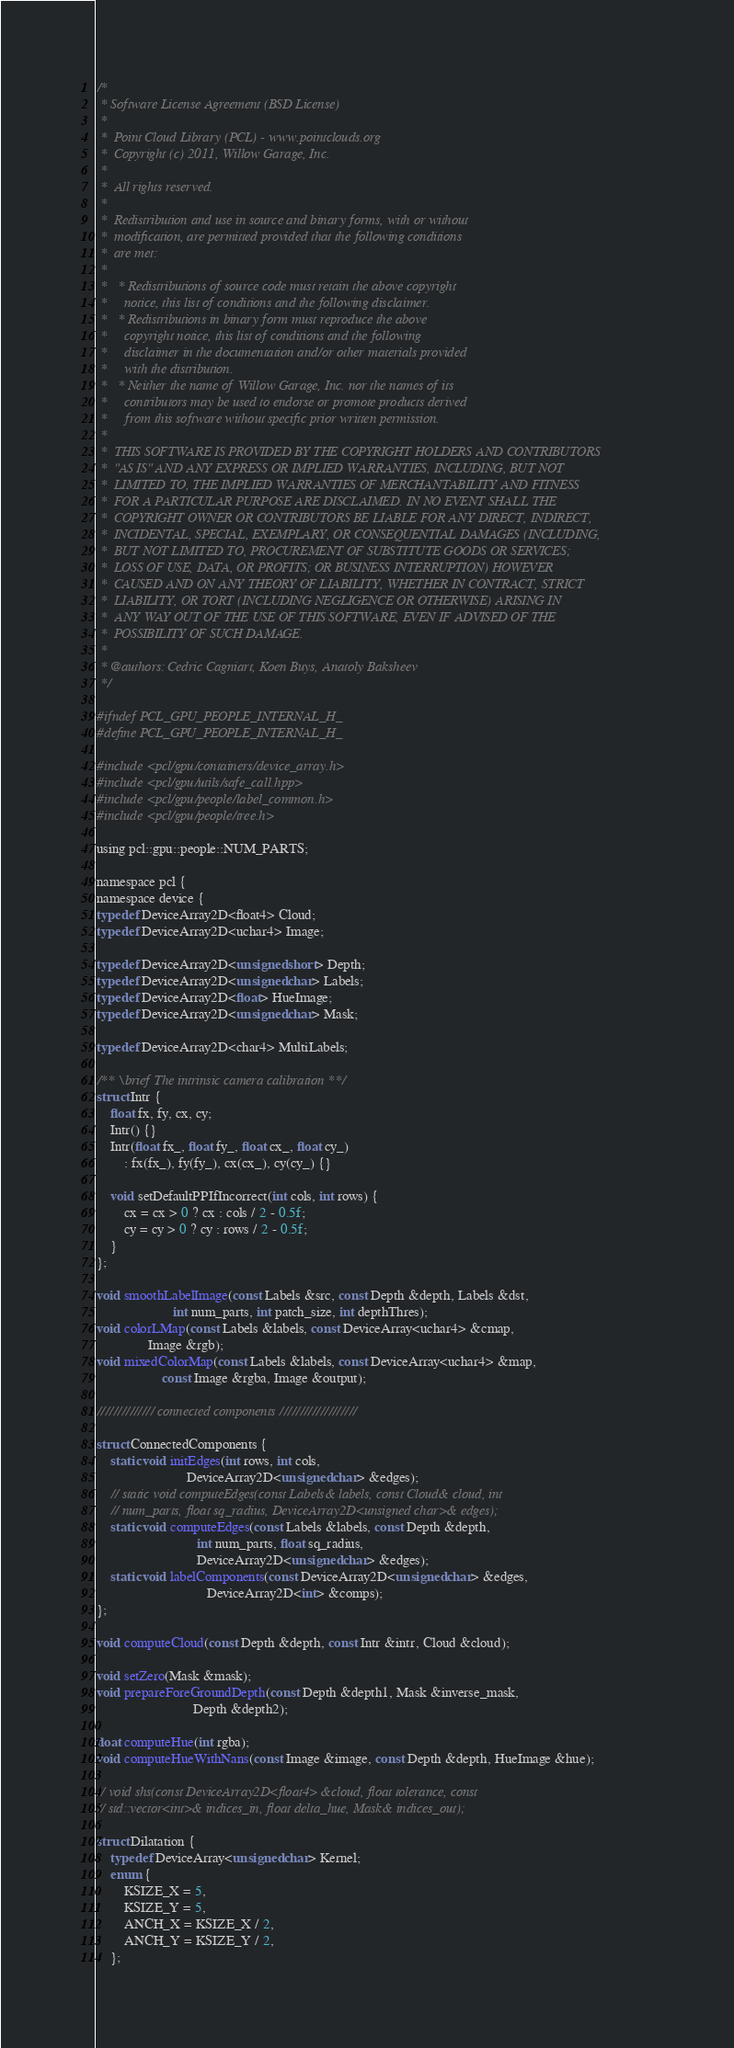Convert code to text. <code><loc_0><loc_0><loc_500><loc_500><_C_>/*
 * Software License Agreement (BSD License)
 *
 *  Point Cloud Library (PCL) - www.pointclouds.org
 *  Copyright (c) 2011, Willow Garage, Inc.
 *
 *  All rights reserved.
 *
 *  Redistribution and use in source and binary forms, with or without
 *  modification, are permitted provided that the following conditions
 *  are met:
 *
 *   * Redistributions of source code must retain the above copyright
 *     notice, this list of conditions and the following disclaimer.
 *   * Redistributions in binary form must reproduce the above
 *     copyright notice, this list of conditions and the following
 *     disclaimer in the documentation and/or other materials provided
 *     with the distribution.
 *   * Neither the name of Willow Garage, Inc. nor the names of its
 *     contributors may be used to endorse or promote products derived
 *     from this software without specific prior written permission.
 *
 *  THIS SOFTWARE IS PROVIDED BY THE COPYRIGHT HOLDERS AND CONTRIBUTORS
 *  "AS IS" AND ANY EXPRESS OR IMPLIED WARRANTIES, INCLUDING, BUT NOT
 *  LIMITED TO, THE IMPLIED WARRANTIES OF MERCHANTABILITY AND FITNESS
 *  FOR A PARTICULAR PURPOSE ARE DISCLAIMED. IN NO EVENT SHALL THE
 *  COPYRIGHT OWNER OR CONTRIBUTORS BE LIABLE FOR ANY DIRECT, INDIRECT,
 *  INCIDENTAL, SPECIAL, EXEMPLARY, OR CONSEQUENTIAL DAMAGES (INCLUDING,
 *  BUT NOT LIMITED TO, PROCUREMENT OF SUBSTITUTE GOODS OR SERVICES;
 *  LOSS OF USE, DATA, OR PROFITS; OR BUSINESS INTERRUPTION) HOWEVER
 *  CAUSED AND ON ANY THEORY OF LIABILITY, WHETHER IN CONTRACT, STRICT
 *  LIABILITY, OR TORT (INCLUDING NEGLIGENCE OR OTHERWISE) ARISING IN
 *  ANY WAY OUT OF THE USE OF THIS SOFTWARE, EVEN IF ADVISED OF THE
 *  POSSIBILITY OF SUCH DAMAGE.
 *
 * @authors: Cedric Cagniart, Koen Buys, Anatoly Baksheev
 */

#ifndef PCL_GPU_PEOPLE_INTERNAL_H_
#define PCL_GPU_PEOPLE_INTERNAL_H_

#include <pcl/gpu/containers/device_array.h>
#include <pcl/gpu/utils/safe_call.hpp>
#include <pcl/gpu/people/label_common.h>
#include <pcl/gpu/people/tree.h>

using pcl::gpu::people::NUM_PARTS;

namespace pcl {
namespace device {
typedef DeviceArray2D<float4> Cloud;
typedef DeviceArray2D<uchar4> Image;

typedef DeviceArray2D<unsigned short> Depth;
typedef DeviceArray2D<unsigned char> Labels;
typedef DeviceArray2D<float> HueImage;
typedef DeviceArray2D<unsigned char> Mask;

typedef DeviceArray2D<char4> MultiLabels;

/** \brief The intrinsic camera calibration **/
struct Intr {
    float fx, fy, cx, cy;
    Intr() {}
    Intr(float fx_, float fy_, float cx_, float cy_)
        : fx(fx_), fy(fy_), cx(cx_), cy(cy_) {}

    void setDefaultPPIfIncorrect(int cols, int rows) {
        cx = cx > 0 ? cx : cols / 2 - 0.5f;
        cy = cy > 0 ? cy : rows / 2 - 0.5f;
    }
};

void smoothLabelImage(const Labels &src, const Depth &depth, Labels &dst,
                      int num_parts, int patch_size, int depthThres);
void colorLMap(const Labels &labels, const DeviceArray<uchar4> &cmap,
               Image &rgb);
void mixedColorMap(const Labels &labels, const DeviceArray<uchar4> &map,
                   const Image &rgba, Image &output);

////////////// connected components ///////////////////

struct ConnectedComponents {
    static void initEdges(int rows, int cols,
                          DeviceArray2D<unsigned char> &edges);
    // static void computeEdges(const Labels& labels, const Cloud& cloud, int
    // num_parts, float sq_radius, DeviceArray2D<unsigned char>& edges);
    static void computeEdges(const Labels &labels, const Depth &depth,
                             int num_parts, float sq_radius,
                             DeviceArray2D<unsigned char> &edges);
    static void labelComponents(const DeviceArray2D<unsigned char> &edges,
                                DeviceArray2D<int> &comps);
};

void computeCloud(const Depth &depth, const Intr &intr, Cloud &cloud);

void setZero(Mask &mask);
void prepareForeGroundDepth(const Depth &depth1, Mask &inverse_mask,
                            Depth &depth2);

float computeHue(int rgba);
void computeHueWithNans(const Image &image, const Depth &depth, HueImage &hue);

// void shs(const DeviceArray2D<float4> &cloud, float tolerance, const
// std::vector<int>& indices_in, float delta_hue, Mask& indices_out);

struct Dilatation {
    typedef DeviceArray<unsigned char> Kernel;
    enum {
        KSIZE_X = 5,
        KSIZE_Y = 5,
        ANCH_X = KSIZE_X / 2,
        ANCH_Y = KSIZE_Y / 2,
    };
</code> 